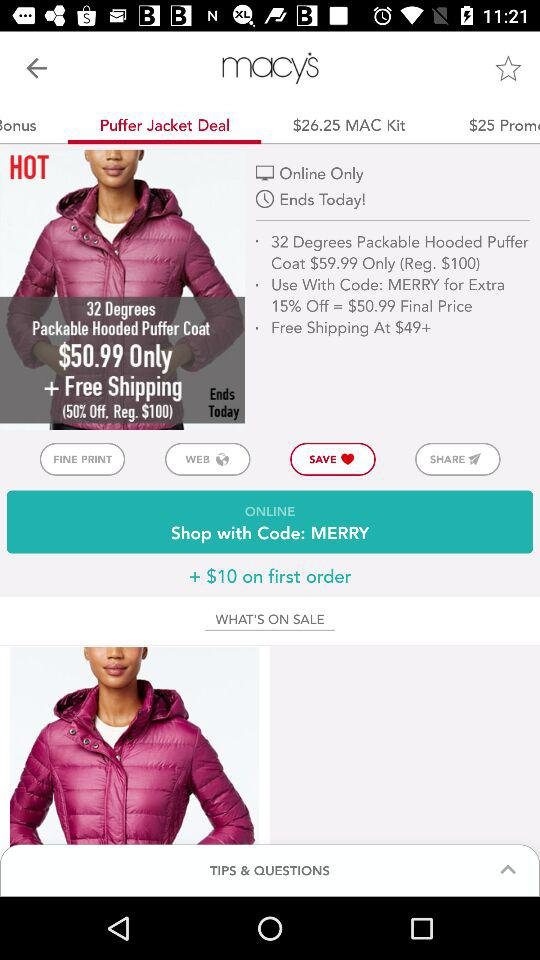What is the final price given on the screen after 15% off? The final price is $50.99. 